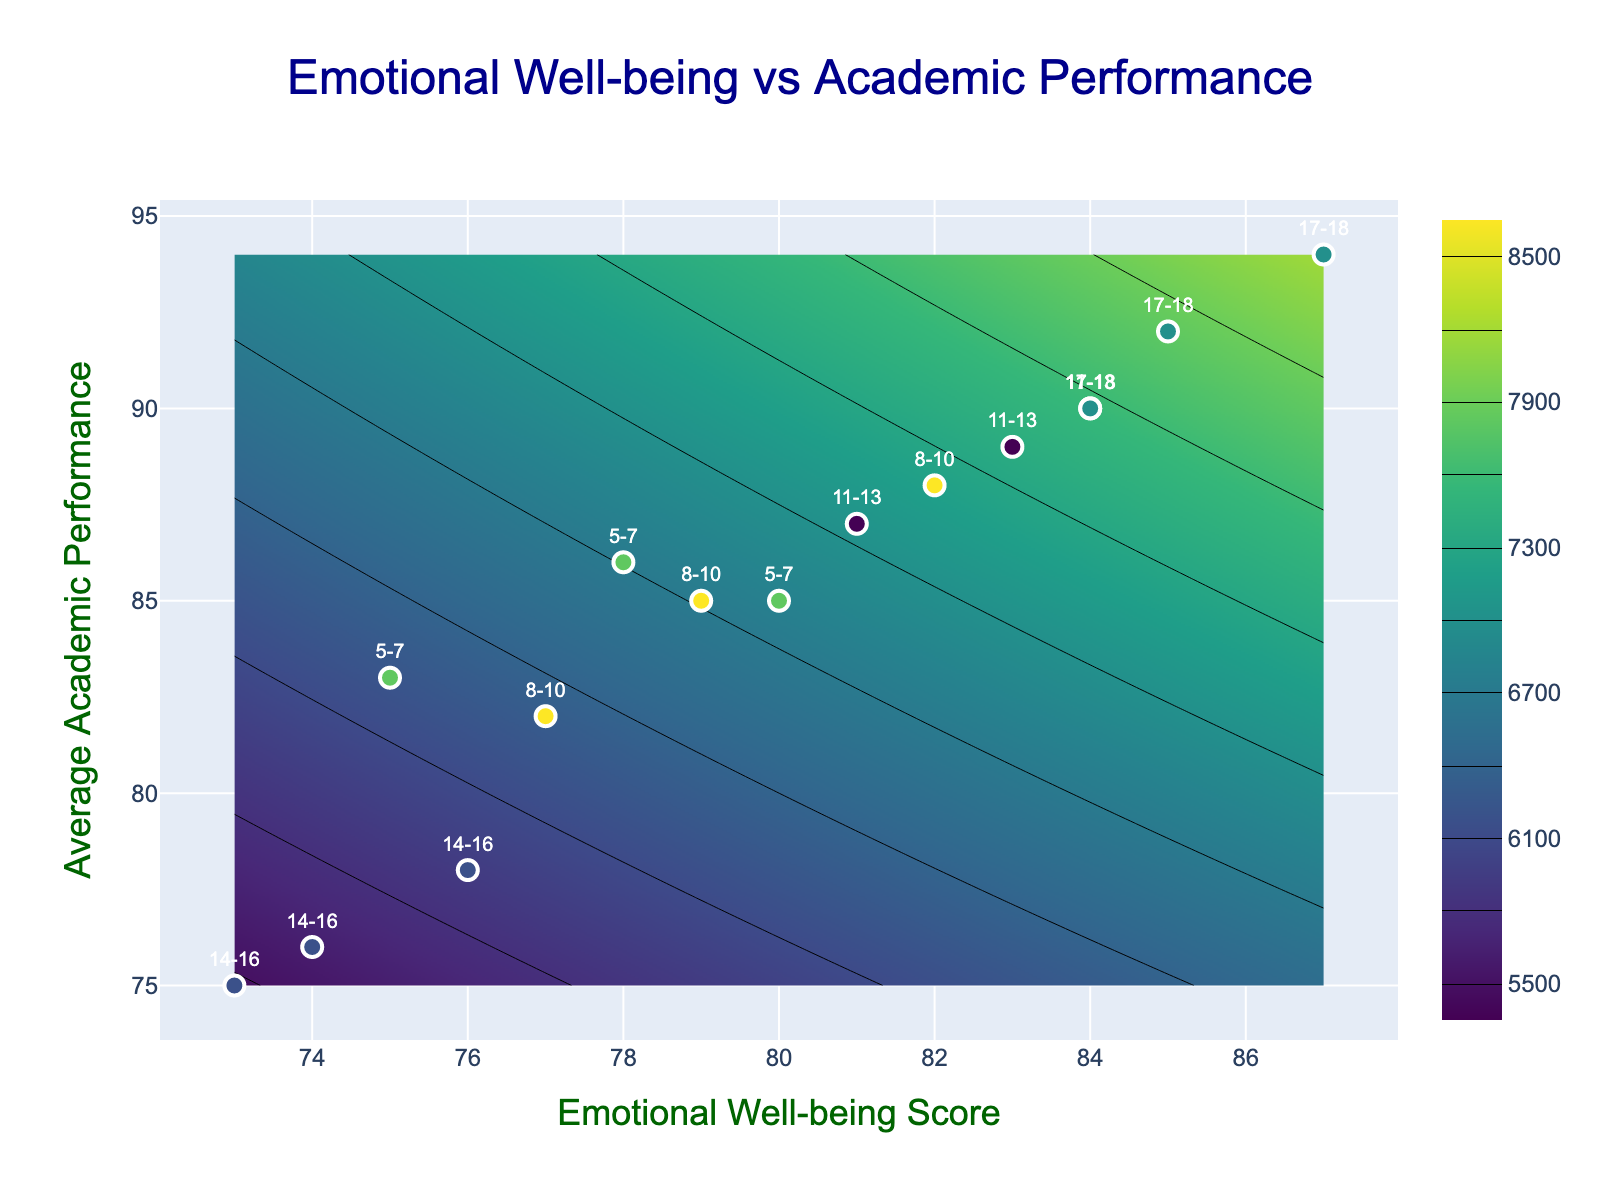What is the title of the contour plot? The title of any plot is usually found at the top of the figure. In this plot, it is clearly stated as "Emotional Well-being vs Academic Performance."
Answer: Emotional Well-being vs Academic Performance What are the labels for the x-axis and y-axis? The x-axis label is usually positioned horizontally below the x-axis, and the y-axis label is vertically positioned to the side of the y-axis. In this plot, the x-axis is labeled "Emotional Well-being Score" and the y-axis is labeled "Average Academic Performance."
Answer: Emotional Well-being Score, Average Academic Performance How many distinct age groups are represented in the scatter plot and what are they? By examining the labeled data points and their associated age group labels, one can identify four different age groups in the scatter plot. These groups are "5-7," "8-10," "11-13," and "14-16," "17-18."
Answer: 5 Which age group has the highest scatter point on the y-axis? Observing the y-axis values for each age-labeled data point, the highest point corresponds to the 17-18 age group at a performance level of 94, which is the highest among all groups.
Answer: 17-18 What is the trend between Emotional Well-being Score and Average Academic Performance based on the contour intervals? The contour plot shows varying shades indicating different ranges. By observing the gradient and positioning of these contours, it's apparent there is a positive correlation – higher emotional well-being scores generally align with higher academic performance scores.
Answer: Positive correlation Which age group shows the highest emotional well-being score and what is it? Looking at the scatter plot markers, the highest emotional well-being score is 87, and it belongs to the age group 17-18.
Answer: 17-18 How does the group aged 14-16 compare in terms of emotional well-being and academic performance with the group aged 11-13? By comparing the scatter points, the 14-16 age group has generally lower emotional well-being scores (73-76) and lower academic performance scores (75-78) compared to the 11-13 age group which has higher values in both metrics (81-84 for well-being and 87-90 for performance).
Answer: 14-16 have lower scores Which age group data points are closest together on the plot? Observing the scatter points for proximity, the age group 14-16 has data points clustered closely together with emotional well-being scores ranging narrowly from 73 to 76 and academic performances from 75 to 78.
Answer: 14-16 What is the approximate emotional well-being score range for the age group 8-10? To find this, we refer to the scatter points labeled with "8-10". The emotional well-being scores for this group range roughly between 77 and 82.
Answer: 77-82 Are there any age groups that do not overlap with others in terms of emotional well-being and academic performance? Checking the scatter plot labels and their positions, the age group 14-16 stands apart as it has one of the lowest ranges in both emotional well-being (73-76) and academic performance (75-78), not overlapping with the significantly higher ranges of other groups.
Answer: 14-16 